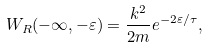<formula> <loc_0><loc_0><loc_500><loc_500>W _ { R } ( - \infty , - \varepsilon ) = \frac { k ^ { 2 } } { 2 m } e ^ { - 2 \varepsilon / \tau } ,</formula> 